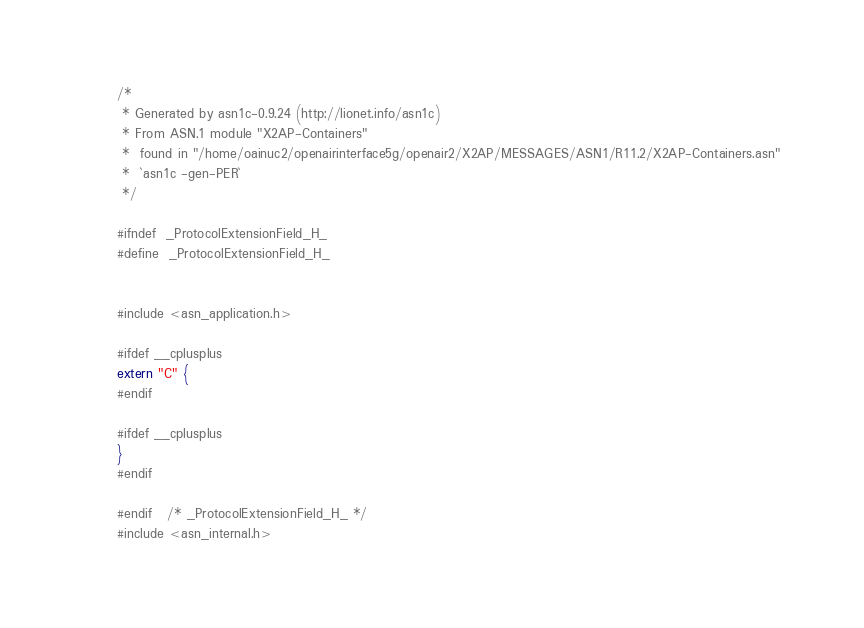Convert code to text. <code><loc_0><loc_0><loc_500><loc_500><_C_>/*
 * Generated by asn1c-0.9.24 (http://lionet.info/asn1c)
 * From ASN.1 module "X2AP-Containers"
 * 	found in "/home/oainuc2/openairinterface5g/openair2/X2AP/MESSAGES/ASN1/R11.2/X2AP-Containers.asn"
 * 	`asn1c -gen-PER`
 */

#ifndef	_ProtocolExtensionField_H_
#define	_ProtocolExtensionField_H_


#include <asn_application.h>

#ifdef __cplusplus
extern "C" {
#endif

#ifdef __cplusplus
}
#endif

#endif	/* _ProtocolExtensionField_H_ */
#include <asn_internal.h>
</code> 